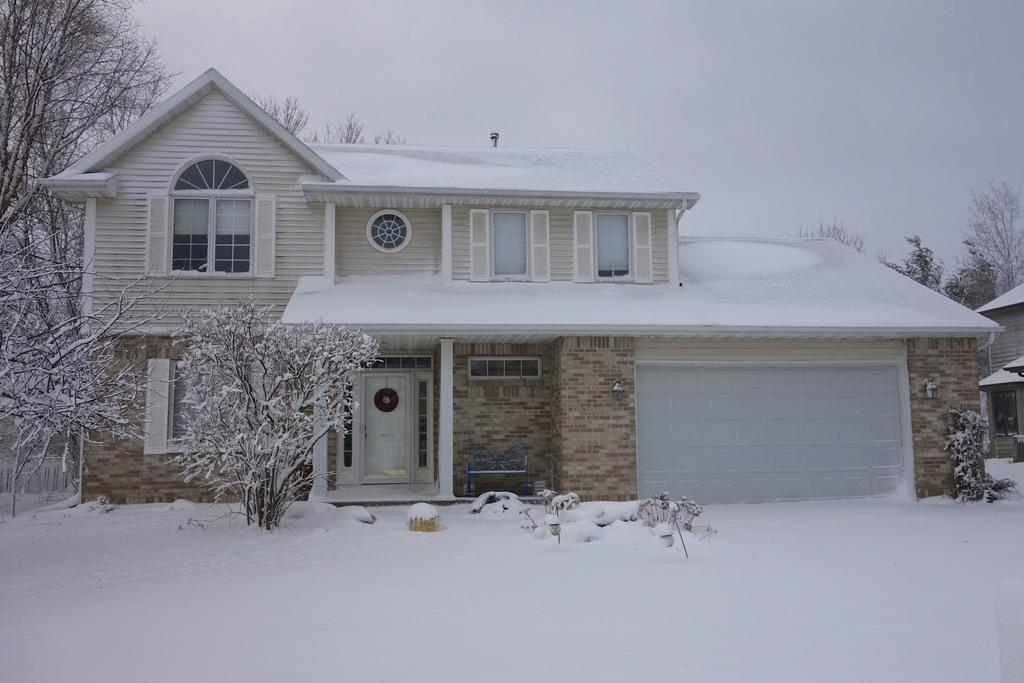What type of weather condition is depicted at the bottom of the image? There is snow at the bottom of the image. What can be seen in the middle of the image? There are plants and a house in the middle of the image. What is located behind the plants and house? There are trees visible behind the plants and house. What is visible at the top of the image? The sky is visible at the top of the image. Can you tell me how many insects are crawling on the board in the image? There is no board or insects present in the image. What type of debt is being discussed in the image? There is no discussion of debt in the image; it features snow, plants, a house, trees, and the sky. 